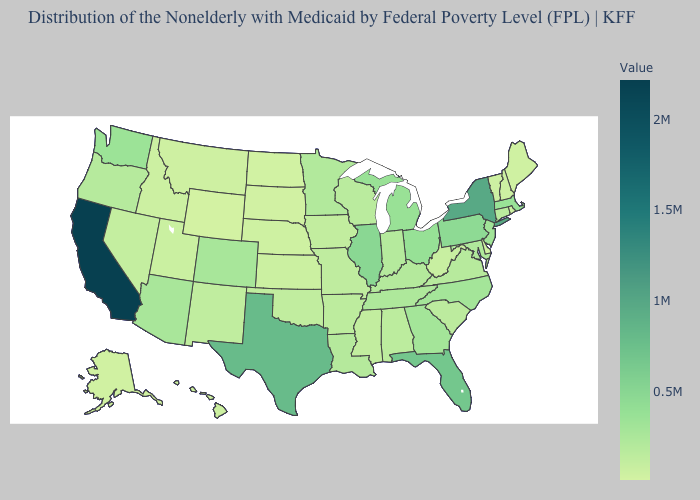Does Illinois have the highest value in the MidWest?
Concise answer only. Yes. Among the states that border Vermont , which have the highest value?
Short answer required. New York. Which states hav the highest value in the South?
Answer briefly. Texas. Among the states that border California , does Arizona have the lowest value?
Write a very short answer. No. 